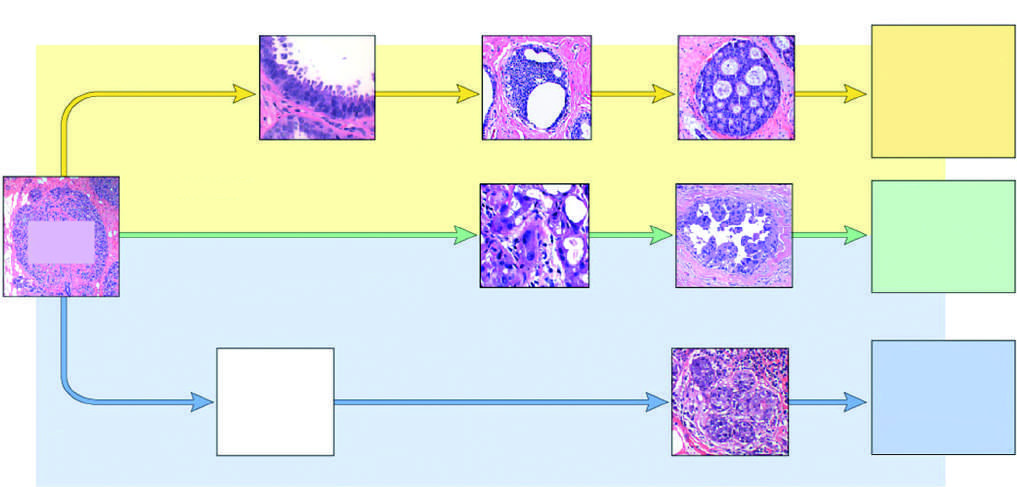s advanced organizing pneumonia classified as basal-like by gene expression profiling?
Answer the question using a single word or phrase. No 